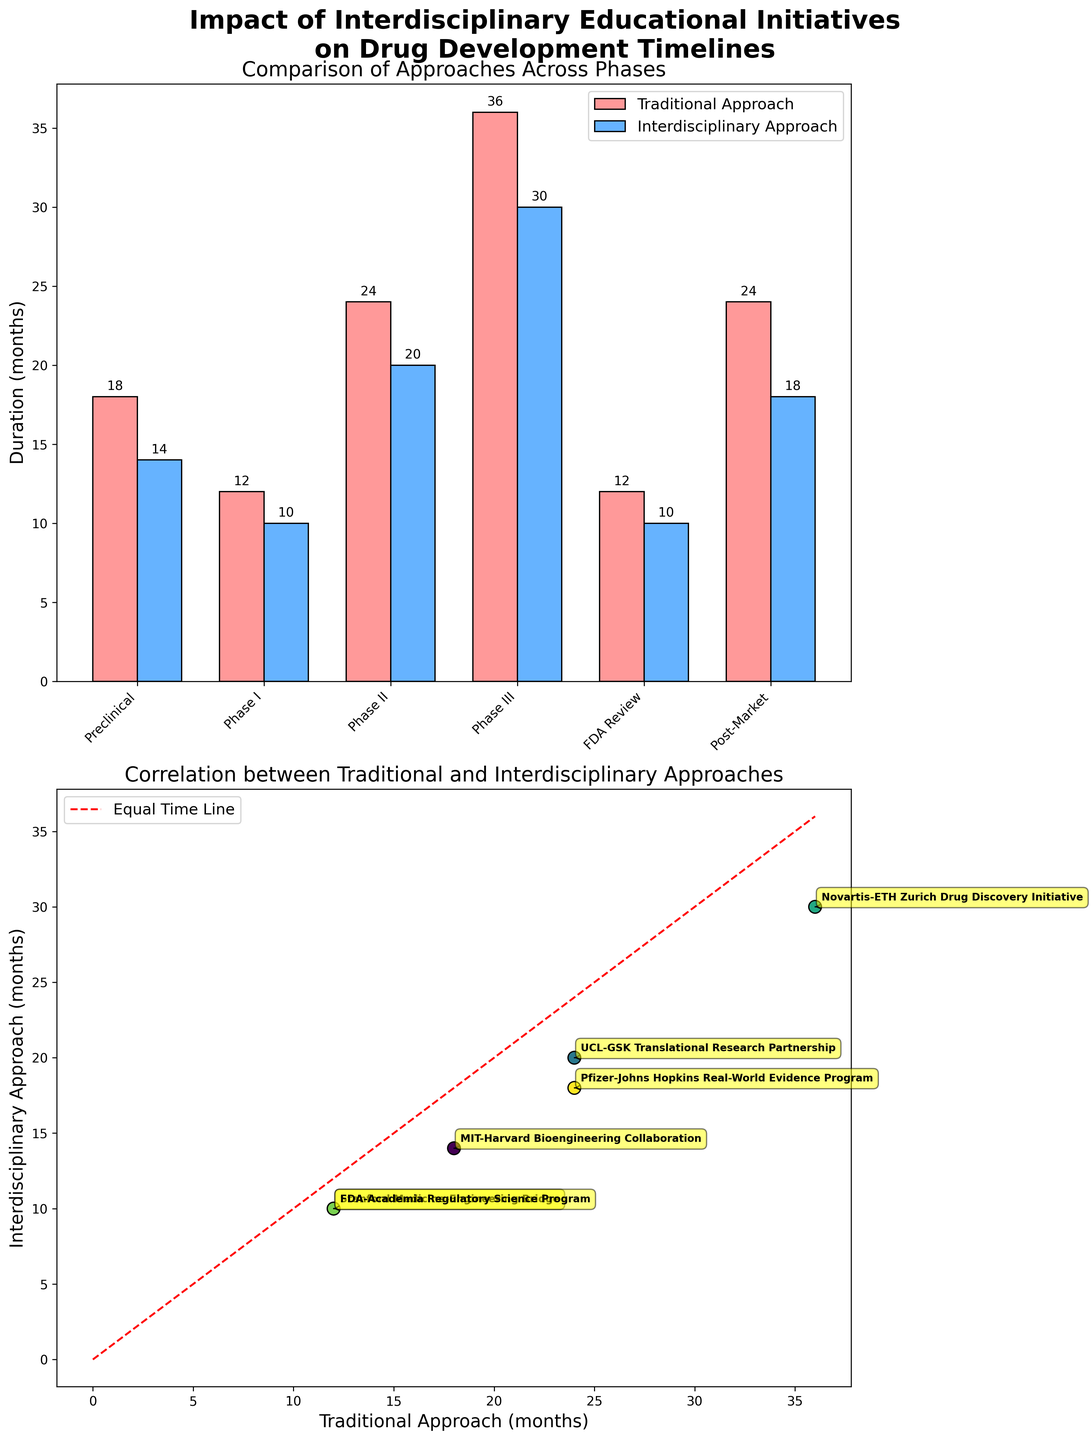What is the title of the figure? The title is typically the first thing we see on the figure. The title here is present at the top of the plot, making it easy to identify.
Answer: Impact of Interdisciplinary Educational Initiatives on Drug Development Timelines What color is used to represent the 'Traditional Approach' in the bar plot? The 'Traditional Approach' bars are filled with a specific color which is #ff9999, represented in real life as a pinkish hue.
Answer: Pinkish Which phase shows the greatest reduction in development time when using the Interdisciplinary Approach compared to the Traditional Approach? By examining the difference in bar heights for each phase, we can see that 'Phase III' has a difference of 6 months, the largest among all phases.
Answer: Phase III What is the difference in time between the Traditional and Interdisciplinary Approach for FDA Review? The Traditional Approach takes 12 months, and the Interdisciplinary Approach takes 10 months. Subtracting these gives 2 months.
Answer: 2 months How many programs are involved in the study? Each dot in the scatter plot is annotated with the name of the program. The total number of unique annotations gives the number of programs involved. Counting these annotations, we see there are six.
Answer: 6 Which program is associated with the 'Post-Market' phase? In the scatter plot, each point is labeled with a program name. By locating the 'Post-Market' phase on the x-axis in the bar plot, and finding the corresponding point in the scatter plot, we can see the label "Pfizer-Johns Hopkins Real-World Evidence Program."
Answer: Pfizer-Johns Hopkins Real-World Evidence Program In which phase is the difference between the two approaches the smallest? By comparing the differences between the heights of the pairs of bars for all phases, we see that the 'FDA Review' phase shows the smallest difference of 2 months.
Answer: FDA Review Which approach had a shorter duration in the Preclinical phase and by how many months? The Preclinical phase bars show 'Traditional Approach' at 18 months and 'Interdisciplinary Approach' at 14 months. Subtracting these, the 'Interdisciplinary Approach' is 4 months shorter.
Answer: Interdisciplinary Approach, 4 months Does any phase show the same duration for both approaches? The scatter plot features a dashed red line representing equal durations for both approaches. Seeing if any point lies directly on this line would indicate equal durations; here, none do.
Answer: No Which phase has the longest duration under the Traditional Approach? The bar plot shows different phase durations. The highest bar corresponds to the 'Phase III', showing 36 months.
Answer: Phase III 